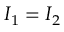<formula> <loc_0><loc_0><loc_500><loc_500>I _ { 1 } = I _ { 2 }</formula> 